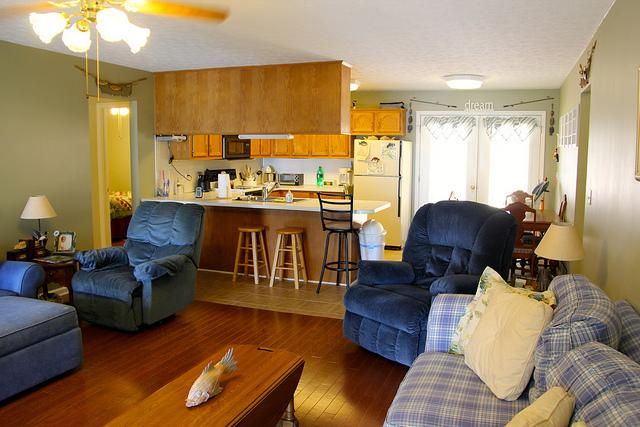What is on the brown table near the couch?

Choices:
A) cat
B) baby
C) fish
D) apple fish 